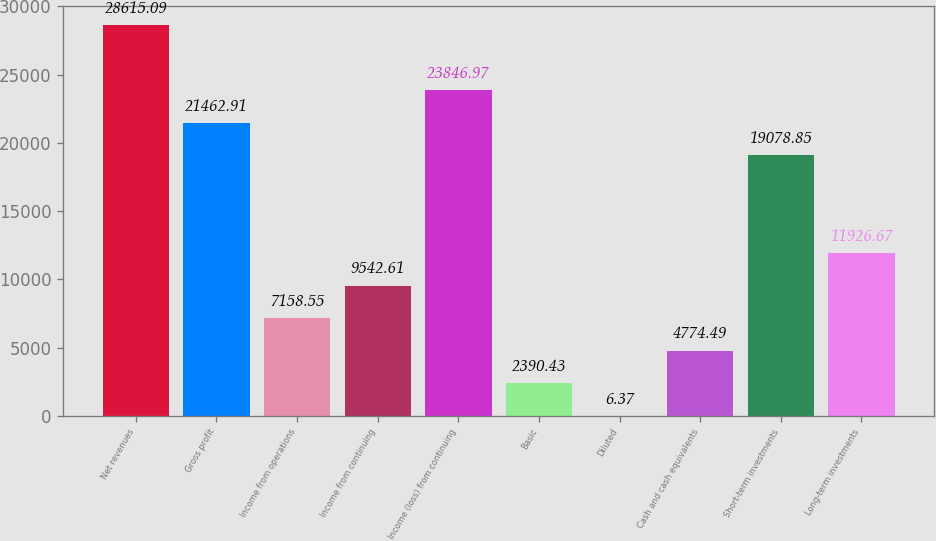Convert chart. <chart><loc_0><loc_0><loc_500><loc_500><bar_chart><fcel>Net revenues<fcel>Gross profit<fcel>Income from operations<fcel>Income from continuing<fcel>Income (loss) from continuing<fcel>Basic<fcel>Diluted<fcel>Cash and cash equivalents<fcel>Short-term investments<fcel>Long-term investments<nl><fcel>28615.1<fcel>21462.9<fcel>7158.55<fcel>9542.61<fcel>23847<fcel>2390.43<fcel>6.37<fcel>4774.49<fcel>19078.8<fcel>11926.7<nl></chart> 